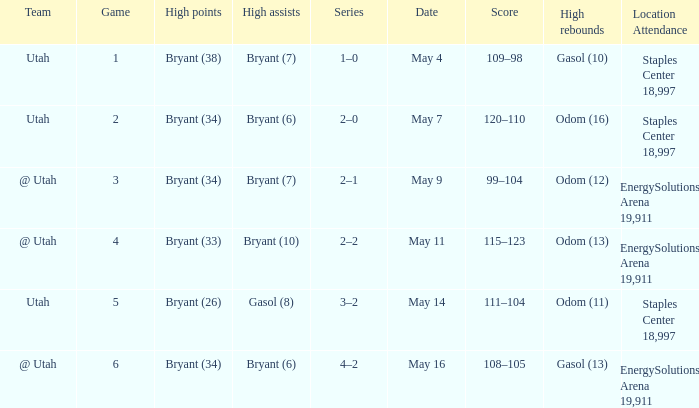What is the High rebounds with a High assists with bryant (7), and a Team of @ utah? Odom (12). 